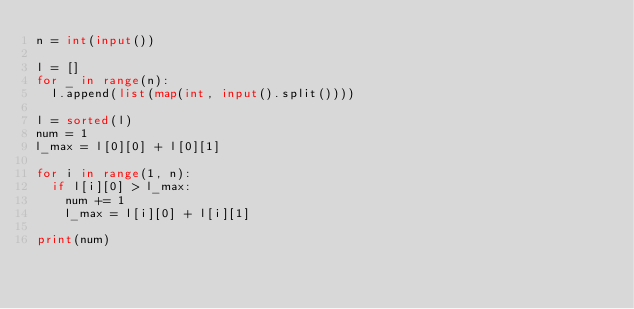<code> <loc_0><loc_0><loc_500><loc_500><_Python_>n = int(input())

l = []
for _ in range(n):
  l.append(list(map(int, input().split())))
  
l = sorted(l)
num = 1
l_max = l[0][0] + l[0][1]

for i in range(1, n):
  if l[i][0] > l_max:
    num += 1
    l_max = l[i][0] + l[i][1]
    
print(num)</code> 